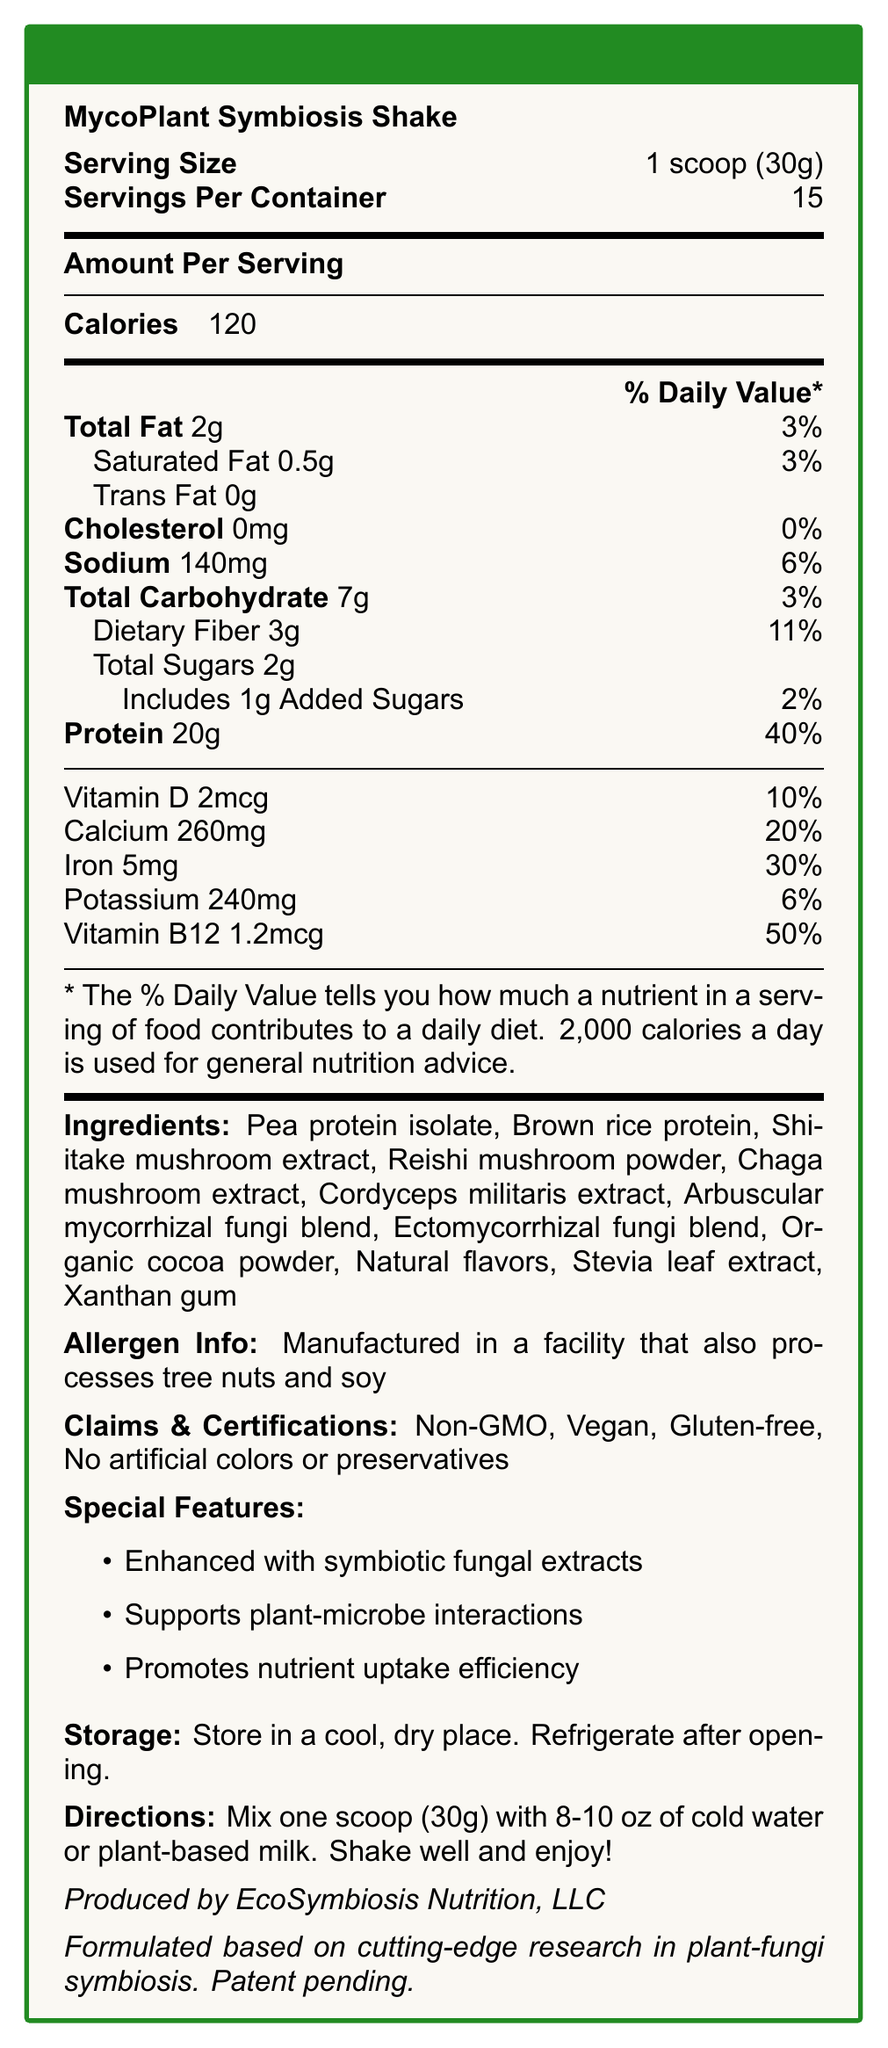what is the serving size? The serving size is explicitly mentioned in the document as "1 scoop (30g)."
Answer: 1 scoop (30g) how many servings are in the container? The document states "Servings Per Container: 15."
Answer: 15 how much protein is in one serving? The document lists "Protein: 20g."
Answer: 20g what is the total fat content per serving? The document indicates "Total Fat: 2g."
Answer: 2g how much dietary fiber is in each serving? The document notes "Dietary Fiber: 3g."
Answer: 3g how much calcium does one serving provide? The document specifies "Calcium: 260mg."
Answer: 260mg how many calories are in one serving of this shake? The document states "Calories: 120."
Answer: 120 what is the primary ingredient in the shake? The first ingredient listed is "Pea protein isolate."
Answer: Pea protein isolate does the shake contain any cholesterol? The document specifies "Cholesterol: 0mg."
Answer: No is the product gluten-free? The document includes "Gluten-free" under Claims & Certifications.
Answer: Yes what are the special features of this shake? The document lists these under "Special Features."
Answer: Enhanced with symbiotic fungal extracts, Supports plant-microbe interactions, Promotes nutrient uptake efficiency how much potassium is in one serving? The document specifies "Potassium: 240mg."
Answer: 240mg what are the directions for preparing the shake? The directions are provided near the end of the document.
Answer: Mix one scoop (30g) with 8-10 oz of cold water or plant-based milk. Shake well and enjoy! Which company produces the MycoPlant Symbiosis Shake? A. Nature's Best B. EcoSymbiosis Nutrition, LLC C. HealthFirst Nutrition D. Organic Life The document indicates "Produced by EcoSymbiosis Nutrition, LLC."
Answer: B What is the daily value percentage of Vitamin B12 per serving? A. 20% B. 30% C. 50% D. 100% The document lists "Vitamin B12: 1.2mcg, Daily Value: 50%."
Answer: C do the ingredients include any artificial preservatives? The document claims "No artificial colors or preservatives" under Claims & Certifications.
Answer: No Is this product suitable for vegans? The document includes "Vegan" under Claims & Certifications.
Answer: Yes Summarize the main features and nutritional content of the MycoPlant Symbiosis Shake. The document highlights the nutritional benefits, including the macronutrient content and daily value percentages of vitamins and minerals, along with the unique ingredients and claims supporting plant-fungi symbiosis.
Answer: The MycoPlant Symbiosis Shake is a plant-based protein shake fortified with symbiotic fungal extracts, providing 20g of protein and 120 calories per serving. It includes ingredients like pea protein isolate, brown rice protein, and various mushroom extracts. It is gluten-free, non-GMO, and free from artificial colors and preservatives. The shake offers vitamins and minerals such as calcium, iron, potassium, Vitamin D, and Vitamin B12. Special features promote plant-microbe interactions and nutrient uptake efficiency. What is the percentage of daily value for total carbohydrates contributed by one serving? The document indicates "Total Carbohydrate: 7g, Daily Value: 3%."
Answer: 3% Does the document state how long the product needs to be stored in a refrigerator after opening? The document only specifies "Refrigerate after opening" but does not mention a specific duration.
Answer: No 